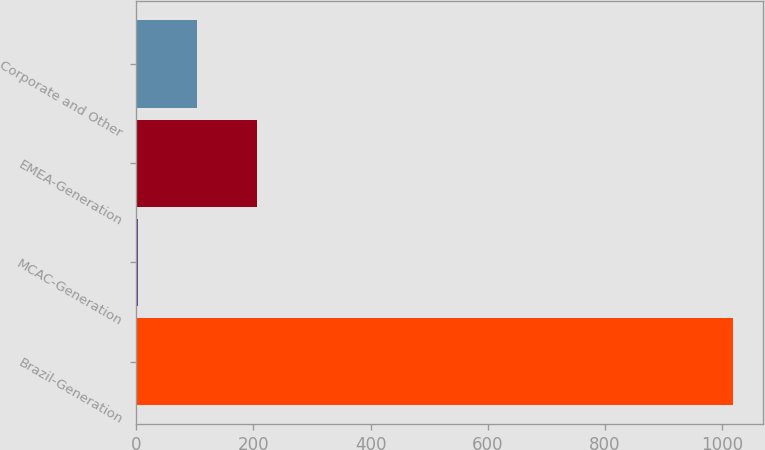<chart> <loc_0><loc_0><loc_500><loc_500><bar_chart><fcel>Brazil-Generation<fcel>MCAC-Generation<fcel>EMEA-Generation<fcel>Corporate and Other<nl><fcel>1019<fcel>2<fcel>205.4<fcel>103.7<nl></chart> 